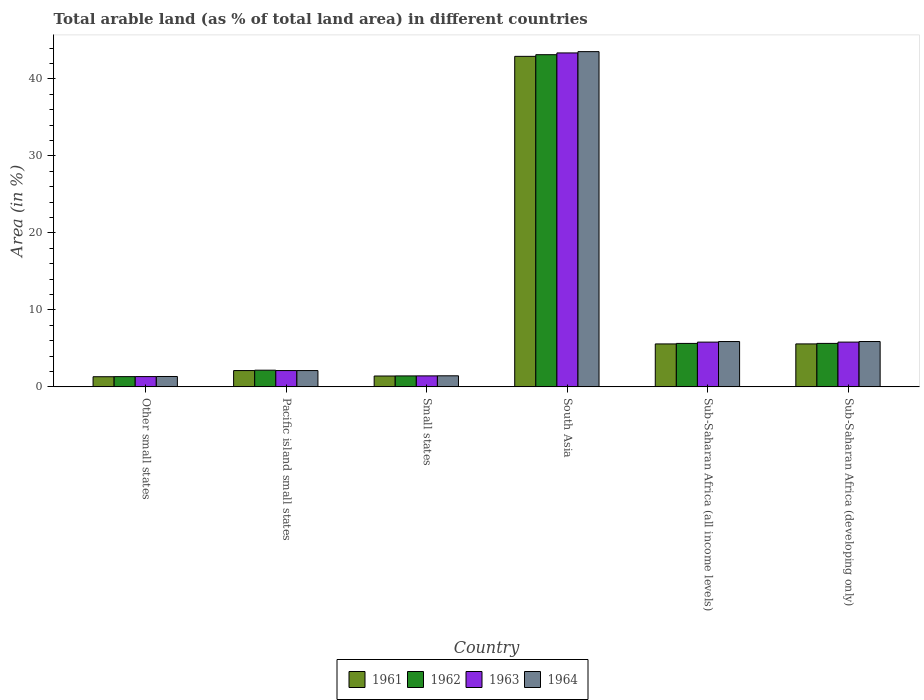Are the number of bars on each tick of the X-axis equal?
Offer a very short reply. Yes. How many bars are there on the 6th tick from the left?
Your answer should be very brief. 4. How many bars are there on the 6th tick from the right?
Ensure brevity in your answer.  4. What is the label of the 4th group of bars from the left?
Offer a very short reply. South Asia. What is the percentage of arable land in 1961 in South Asia?
Provide a short and direct response. 42.92. Across all countries, what is the maximum percentage of arable land in 1963?
Your response must be concise. 43.36. Across all countries, what is the minimum percentage of arable land in 1961?
Offer a very short reply. 1.32. In which country was the percentage of arable land in 1963 maximum?
Make the answer very short. South Asia. In which country was the percentage of arable land in 1961 minimum?
Your response must be concise. Other small states. What is the total percentage of arable land in 1962 in the graph?
Offer a very short reply. 59.34. What is the difference between the percentage of arable land in 1963 in South Asia and that in Sub-Saharan Africa (developing only)?
Your answer should be compact. 37.55. What is the difference between the percentage of arable land in 1964 in Sub-Saharan Africa (all income levels) and the percentage of arable land in 1963 in Other small states?
Make the answer very short. 4.55. What is the average percentage of arable land in 1962 per country?
Offer a very short reply. 9.89. What is the difference between the percentage of arable land of/in 1964 and percentage of arable land of/in 1961 in Sub-Saharan Africa (all income levels)?
Keep it short and to the point. 0.31. In how many countries, is the percentage of arable land in 1962 greater than 40 %?
Offer a terse response. 1. What is the ratio of the percentage of arable land in 1964 in Other small states to that in Pacific island small states?
Give a very brief answer. 0.64. Is the difference between the percentage of arable land in 1964 in South Asia and Sub-Saharan Africa (all income levels) greater than the difference between the percentage of arable land in 1961 in South Asia and Sub-Saharan Africa (all income levels)?
Keep it short and to the point. Yes. What is the difference between the highest and the second highest percentage of arable land in 1962?
Your answer should be very brief. -37.49. What is the difference between the highest and the lowest percentage of arable land in 1964?
Ensure brevity in your answer.  42.18. In how many countries, is the percentage of arable land in 1962 greater than the average percentage of arable land in 1962 taken over all countries?
Your answer should be compact. 1. Is the sum of the percentage of arable land in 1963 in Small states and South Asia greater than the maximum percentage of arable land in 1961 across all countries?
Your answer should be compact. Yes. Is it the case that in every country, the sum of the percentage of arable land in 1962 and percentage of arable land in 1961 is greater than the sum of percentage of arable land in 1964 and percentage of arable land in 1963?
Make the answer very short. No. How many bars are there?
Your answer should be compact. 24. What is the difference between two consecutive major ticks on the Y-axis?
Provide a short and direct response. 10. Are the values on the major ticks of Y-axis written in scientific E-notation?
Ensure brevity in your answer.  No. Does the graph contain any zero values?
Offer a very short reply. No. How many legend labels are there?
Your answer should be compact. 4. How are the legend labels stacked?
Give a very brief answer. Horizontal. What is the title of the graph?
Your answer should be compact. Total arable land (as % of total land area) in different countries. Does "1967" appear as one of the legend labels in the graph?
Offer a very short reply. No. What is the label or title of the X-axis?
Make the answer very short. Country. What is the label or title of the Y-axis?
Make the answer very short. Area (in %). What is the Area (in %) of 1961 in Other small states?
Provide a short and direct response. 1.32. What is the Area (in %) of 1962 in Other small states?
Ensure brevity in your answer.  1.33. What is the Area (in %) in 1963 in Other small states?
Provide a succinct answer. 1.34. What is the Area (in %) of 1964 in Other small states?
Ensure brevity in your answer.  1.35. What is the Area (in %) in 1961 in Pacific island small states?
Give a very brief answer. 2.12. What is the Area (in %) in 1962 in Pacific island small states?
Your response must be concise. 2.17. What is the Area (in %) of 1963 in Pacific island small states?
Your response must be concise. 2.12. What is the Area (in %) in 1964 in Pacific island small states?
Ensure brevity in your answer.  2.12. What is the Area (in %) in 1961 in Small states?
Your response must be concise. 1.41. What is the Area (in %) of 1962 in Small states?
Keep it short and to the point. 1.42. What is the Area (in %) in 1963 in Small states?
Your response must be concise. 1.43. What is the Area (in %) of 1964 in Small states?
Make the answer very short. 1.44. What is the Area (in %) in 1961 in South Asia?
Provide a short and direct response. 42.92. What is the Area (in %) in 1962 in South Asia?
Your answer should be compact. 43.13. What is the Area (in %) in 1963 in South Asia?
Your answer should be very brief. 43.36. What is the Area (in %) of 1964 in South Asia?
Ensure brevity in your answer.  43.53. What is the Area (in %) in 1961 in Sub-Saharan Africa (all income levels)?
Your answer should be very brief. 5.58. What is the Area (in %) in 1962 in Sub-Saharan Africa (all income levels)?
Give a very brief answer. 5.64. What is the Area (in %) of 1963 in Sub-Saharan Africa (all income levels)?
Provide a short and direct response. 5.81. What is the Area (in %) of 1964 in Sub-Saharan Africa (all income levels)?
Your answer should be very brief. 5.89. What is the Area (in %) in 1961 in Sub-Saharan Africa (developing only)?
Your response must be concise. 5.58. What is the Area (in %) of 1962 in Sub-Saharan Africa (developing only)?
Ensure brevity in your answer.  5.65. What is the Area (in %) in 1963 in Sub-Saharan Africa (developing only)?
Your answer should be very brief. 5.81. What is the Area (in %) in 1964 in Sub-Saharan Africa (developing only)?
Your response must be concise. 5.89. Across all countries, what is the maximum Area (in %) of 1961?
Provide a succinct answer. 42.92. Across all countries, what is the maximum Area (in %) of 1962?
Keep it short and to the point. 43.13. Across all countries, what is the maximum Area (in %) of 1963?
Your response must be concise. 43.36. Across all countries, what is the maximum Area (in %) in 1964?
Provide a succinct answer. 43.53. Across all countries, what is the minimum Area (in %) of 1961?
Give a very brief answer. 1.32. Across all countries, what is the minimum Area (in %) in 1962?
Provide a short and direct response. 1.33. Across all countries, what is the minimum Area (in %) in 1963?
Provide a short and direct response. 1.34. Across all countries, what is the minimum Area (in %) of 1964?
Give a very brief answer. 1.35. What is the total Area (in %) in 1961 in the graph?
Provide a succinct answer. 58.92. What is the total Area (in %) of 1962 in the graph?
Provide a succinct answer. 59.34. What is the total Area (in %) in 1963 in the graph?
Your answer should be very brief. 59.87. What is the total Area (in %) of 1964 in the graph?
Provide a succinct answer. 60.21. What is the difference between the Area (in %) in 1961 in Other small states and that in Pacific island small states?
Offer a very short reply. -0.8. What is the difference between the Area (in %) in 1962 in Other small states and that in Pacific island small states?
Make the answer very short. -0.84. What is the difference between the Area (in %) of 1963 in Other small states and that in Pacific island small states?
Your response must be concise. -0.78. What is the difference between the Area (in %) of 1964 in Other small states and that in Pacific island small states?
Ensure brevity in your answer.  -0.77. What is the difference between the Area (in %) in 1961 in Other small states and that in Small states?
Your response must be concise. -0.09. What is the difference between the Area (in %) in 1962 in Other small states and that in Small states?
Give a very brief answer. -0.09. What is the difference between the Area (in %) in 1963 in Other small states and that in Small states?
Provide a succinct answer. -0.09. What is the difference between the Area (in %) of 1964 in Other small states and that in Small states?
Keep it short and to the point. -0.09. What is the difference between the Area (in %) of 1961 in Other small states and that in South Asia?
Your response must be concise. -41.6. What is the difference between the Area (in %) in 1962 in Other small states and that in South Asia?
Give a very brief answer. -41.8. What is the difference between the Area (in %) of 1963 in Other small states and that in South Asia?
Provide a succinct answer. -42.03. What is the difference between the Area (in %) in 1964 in Other small states and that in South Asia?
Your response must be concise. -42.18. What is the difference between the Area (in %) of 1961 in Other small states and that in Sub-Saharan Africa (all income levels)?
Provide a succinct answer. -4.26. What is the difference between the Area (in %) in 1962 in Other small states and that in Sub-Saharan Africa (all income levels)?
Keep it short and to the point. -4.31. What is the difference between the Area (in %) in 1963 in Other small states and that in Sub-Saharan Africa (all income levels)?
Offer a terse response. -4.48. What is the difference between the Area (in %) in 1964 in Other small states and that in Sub-Saharan Africa (all income levels)?
Offer a very short reply. -4.54. What is the difference between the Area (in %) of 1961 in Other small states and that in Sub-Saharan Africa (developing only)?
Ensure brevity in your answer.  -4.26. What is the difference between the Area (in %) in 1962 in Other small states and that in Sub-Saharan Africa (developing only)?
Give a very brief answer. -4.32. What is the difference between the Area (in %) of 1963 in Other small states and that in Sub-Saharan Africa (developing only)?
Your answer should be compact. -4.48. What is the difference between the Area (in %) in 1964 in Other small states and that in Sub-Saharan Africa (developing only)?
Your answer should be very brief. -4.54. What is the difference between the Area (in %) in 1961 in Pacific island small states and that in Small states?
Offer a very short reply. 0.71. What is the difference between the Area (in %) in 1962 in Pacific island small states and that in Small states?
Provide a short and direct response. 0.74. What is the difference between the Area (in %) in 1963 in Pacific island small states and that in Small states?
Make the answer very short. 0.69. What is the difference between the Area (in %) in 1964 in Pacific island small states and that in Small states?
Make the answer very short. 0.68. What is the difference between the Area (in %) in 1961 in Pacific island small states and that in South Asia?
Your answer should be compact. -40.8. What is the difference between the Area (in %) in 1962 in Pacific island small states and that in South Asia?
Give a very brief answer. -40.97. What is the difference between the Area (in %) of 1963 in Pacific island small states and that in South Asia?
Your answer should be very brief. -41.24. What is the difference between the Area (in %) of 1964 in Pacific island small states and that in South Asia?
Give a very brief answer. -41.41. What is the difference between the Area (in %) in 1961 in Pacific island small states and that in Sub-Saharan Africa (all income levels)?
Provide a short and direct response. -3.46. What is the difference between the Area (in %) of 1962 in Pacific island small states and that in Sub-Saharan Africa (all income levels)?
Provide a succinct answer. -3.48. What is the difference between the Area (in %) of 1963 in Pacific island small states and that in Sub-Saharan Africa (all income levels)?
Your answer should be very brief. -3.69. What is the difference between the Area (in %) in 1964 in Pacific island small states and that in Sub-Saharan Africa (all income levels)?
Give a very brief answer. -3.77. What is the difference between the Area (in %) of 1961 in Pacific island small states and that in Sub-Saharan Africa (developing only)?
Ensure brevity in your answer.  -3.46. What is the difference between the Area (in %) in 1962 in Pacific island small states and that in Sub-Saharan Africa (developing only)?
Offer a very short reply. -3.48. What is the difference between the Area (in %) of 1963 in Pacific island small states and that in Sub-Saharan Africa (developing only)?
Your answer should be very brief. -3.7. What is the difference between the Area (in %) in 1964 in Pacific island small states and that in Sub-Saharan Africa (developing only)?
Offer a very short reply. -3.77. What is the difference between the Area (in %) of 1961 in Small states and that in South Asia?
Provide a succinct answer. -41.51. What is the difference between the Area (in %) of 1962 in Small states and that in South Asia?
Provide a short and direct response. -41.71. What is the difference between the Area (in %) of 1963 in Small states and that in South Asia?
Make the answer very short. -41.94. What is the difference between the Area (in %) of 1964 in Small states and that in South Asia?
Your answer should be compact. -42.09. What is the difference between the Area (in %) of 1961 in Small states and that in Sub-Saharan Africa (all income levels)?
Provide a short and direct response. -4.17. What is the difference between the Area (in %) in 1962 in Small states and that in Sub-Saharan Africa (all income levels)?
Your answer should be compact. -4.22. What is the difference between the Area (in %) of 1963 in Small states and that in Sub-Saharan Africa (all income levels)?
Make the answer very short. -4.38. What is the difference between the Area (in %) of 1964 in Small states and that in Sub-Saharan Africa (all income levels)?
Offer a terse response. -4.45. What is the difference between the Area (in %) in 1961 in Small states and that in Sub-Saharan Africa (developing only)?
Ensure brevity in your answer.  -4.17. What is the difference between the Area (in %) of 1962 in Small states and that in Sub-Saharan Africa (developing only)?
Make the answer very short. -4.22. What is the difference between the Area (in %) of 1963 in Small states and that in Sub-Saharan Africa (developing only)?
Your answer should be compact. -4.39. What is the difference between the Area (in %) in 1964 in Small states and that in Sub-Saharan Africa (developing only)?
Keep it short and to the point. -4.45. What is the difference between the Area (in %) in 1961 in South Asia and that in Sub-Saharan Africa (all income levels)?
Provide a succinct answer. 37.34. What is the difference between the Area (in %) of 1962 in South Asia and that in Sub-Saharan Africa (all income levels)?
Offer a terse response. 37.49. What is the difference between the Area (in %) of 1963 in South Asia and that in Sub-Saharan Africa (all income levels)?
Give a very brief answer. 37.55. What is the difference between the Area (in %) of 1964 in South Asia and that in Sub-Saharan Africa (all income levels)?
Your answer should be very brief. 37.64. What is the difference between the Area (in %) in 1961 in South Asia and that in Sub-Saharan Africa (developing only)?
Keep it short and to the point. 37.34. What is the difference between the Area (in %) of 1962 in South Asia and that in Sub-Saharan Africa (developing only)?
Make the answer very short. 37.49. What is the difference between the Area (in %) of 1963 in South Asia and that in Sub-Saharan Africa (developing only)?
Offer a terse response. 37.55. What is the difference between the Area (in %) of 1964 in South Asia and that in Sub-Saharan Africa (developing only)?
Give a very brief answer. 37.64. What is the difference between the Area (in %) in 1961 in Sub-Saharan Africa (all income levels) and that in Sub-Saharan Africa (developing only)?
Keep it short and to the point. -0. What is the difference between the Area (in %) of 1962 in Sub-Saharan Africa (all income levels) and that in Sub-Saharan Africa (developing only)?
Provide a succinct answer. -0. What is the difference between the Area (in %) of 1963 in Sub-Saharan Africa (all income levels) and that in Sub-Saharan Africa (developing only)?
Ensure brevity in your answer.  -0. What is the difference between the Area (in %) of 1964 in Sub-Saharan Africa (all income levels) and that in Sub-Saharan Africa (developing only)?
Your answer should be compact. -0. What is the difference between the Area (in %) of 1961 in Other small states and the Area (in %) of 1962 in Pacific island small states?
Provide a succinct answer. -0.85. What is the difference between the Area (in %) of 1961 in Other small states and the Area (in %) of 1963 in Pacific island small states?
Your answer should be very brief. -0.8. What is the difference between the Area (in %) in 1961 in Other small states and the Area (in %) in 1964 in Pacific island small states?
Provide a succinct answer. -0.8. What is the difference between the Area (in %) of 1962 in Other small states and the Area (in %) of 1963 in Pacific island small states?
Offer a very short reply. -0.79. What is the difference between the Area (in %) in 1962 in Other small states and the Area (in %) in 1964 in Pacific island small states?
Your response must be concise. -0.79. What is the difference between the Area (in %) in 1963 in Other small states and the Area (in %) in 1964 in Pacific island small states?
Make the answer very short. -0.78. What is the difference between the Area (in %) in 1961 in Other small states and the Area (in %) in 1962 in Small states?
Ensure brevity in your answer.  -0.1. What is the difference between the Area (in %) of 1961 in Other small states and the Area (in %) of 1963 in Small states?
Make the answer very short. -0.11. What is the difference between the Area (in %) of 1961 in Other small states and the Area (in %) of 1964 in Small states?
Offer a very short reply. -0.12. What is the difference between the Area (in %) of 1962 in Other small states and the Area (in %) of 1963 in Small states?
Offer a very short reply. -0.1. What is the difference between the Area (in %) of 1962 in Other small states and the Area (in %) of 1964 in Small states?
Your response must be concise. -0.11. What is the difference between the Area (in %) in 1963 in Other small states and the Area (in %) in 1964 in Small states?
Offer a terse response. -0.1. What is the difference between the Area (in %) in 1961 in Other small states and the Area (in %) in 1962 in South Asia?
Your answer should be very brief. -41.82. What is the difference between the Area (in %) of 1961 in Other small states and the Area (in %) of 1963 in South Asia?
Your answer should be very brief. -42.04. What is the difference between the Area (in %) in 1961 in Other small states and the Area (in %) in 1964 in South Asia?
Offer a terse response. -42.21. What is the difference between the Area (in %) in 1962 in Other small states and the Area (in %) in 1963 in South Asia?
Offer a terse response. -42.03. What is the difference between the Area (in %) in 1962 in Other small states and the Area (in %) in 1964 in South Asia?
Your answer should be very brief. -42.2. What is the difference between the Area (in %) in 1963 in Other small states and the Area (in %) in 1964 in South Asia?
Keep it short and to the point. -42.2. What is the difference between the Area (in %) of 1961 in Other small states and the Area (in %) of 1962 in Sub-Saharan Africa (all income levels)?
Your answer should be compact. -4.33. What is the difference between the Area (in %) in 1961 in Other small states and the Area (in %) in 1963 in Sub-Saharan Africa (all income levels)?
Ensure brevity in your answer.  -4.49. What is the difference between the Area (in %) of 1961 in Other small states and the Area (in %) of 1964 in Sub-Saharan Africa (all income levels)?
Your response must be concise. -4.57. What is the difference between the Area (in %) of 1962 in Other small states and the Area (in %) of 1963 in Sub-Saharan Africa (all income levels)?
Give a very brief answer. -4.48. What is the difference between the Area (in %) of 1962 in Other small states and the Area (in %) of 1964 in Sub-Saharan Africa (all income levels)?
Offer a very short reply. -4.56. What is the difference between the Area (in %) in 1963 in Other small states and the Area (in %) in 1964 in Sub-Saharan Africa (all income levels)?
Offer a terse response. -4.55. What is the difference between the Area (in %) in 1961 in Other small states and the Area (in %) in 1962 in Sub-Saharan Africa (developing only)?
Ensure brevity in your answer.  -4.33. What is the difference between the Area (in %) of 1961 in Other small states and the Area (in %) of 1963 in Sub-Saharan Africa (developing only)?
Make the answer very short. -4.49. What is the difference between the Area (in %) of 1961 in Other small states and the Area (in %) of 1964 in Sub-Saharan Africa (developing only)?
Ensure brevity in your answer.  -4.57. What is the difference between the Area (in %) in 1962 in Other small states and the Area (in %) in 1963 in Sub-Saharan Africa (developing only)?
Ensure brevity in your answer.  -4.48. What is the difference between the Area (in %) of 1962 in Other small states and the Area (in %) of 1964 in Sub-Saharan Africa (developing only)?
Your answer should be very brief. -4.56. What is the difference between the Area (in %) in 1963 in Other small states and the Area (in %) in 1964 in Sub-Saharan Africa (developing only)?
Provide a short and direct response. -4.55. What is the difference between the Area (in %) of 1961 in Pacific island small states and the Area (in %) of 1962 in Small states?
Offer a terse response. 0.69. What is the difference between the Area (in %) in 1961 in Pacific island small states and the Area (in %) in 1963 in Small states?
Ensure brevity in your answer.  0.69. What is the difference between the Area (in %) in 1961 in Pacific island small states and the Area (in %) in 1964 in Small states?
Ensure brevity in your answer.  0.68. What is the difference between the Area (in %) in 1962 in Pacific island small states and the Area (in %) in 1963 in Small states?
Your answer should be very brief. 0.74. What is the difference between the Area (in %) in 1962 in Pacific island small states and the Area (in %) in 1964 in Small states?
Your answer should be very brief. 0.73. What is the difference between the Area (in %) of 1963 in Pacific island small states and the Area (in %) of 1964 in Small states?
Your answer should be very brief. 0.68. What is the difference between the Area (in %) of 1961 in Pacific island small states and the Area (in %) of 1962 in South Asia?
Your answer should be very brief. -41.02. What is the difference between the Area (in %) in 1961 in Pacific island small states and the Area (in %) in 1963 in South Asia?
Your answer should be compact. -41.24. What is the difference between the Area (in %) of 1961 in Pacific island small states and the Area (in %) of 1964 in South Asia?
Provide a succinct answer. -41.41. What is the difference between the Area (in %) in 1962 in Pacific island small states and the Area (in %) in 1963 in South Asia?
Provide a succinct answer. -41.2. What is the difference between the Area (in %) in 1962 in Pacific island small states and the Area (in %) in 1964 in South Asia?
Ensure brevity in your answer.  -41.37. What is the difference between the Area (in %) of 1963 in Pacific island small states and the Area (in %) of 1964 in South Asia?
Make the answer very short. -41.41. What is the difference between the Area (in %) of 1961 in Pacific island small states and the Area (in %) of 1962 in Sub-Saharan Africa (all income levels)?
Offer a terse response. -3.53. What is the difference between the Area (in %) of 1961 in Pacific island small states and the Area (in %) of 1963 in Sub-Saharan Africa (all income levels)?
Your response must be concise. -3.69. What is the difference between the Area (in %) in 1961 in Pacific island small states and the Area (in %) in 1964 in Sub-Saharan Africa (all income levels)?
Provide a succinct answer. -3.77. What is the difference between the Area (in %) of 1962 in Pacific island small states and the Area (in %) of 1963 in Sub-Saharan Africa (all income levels)?
Provide a short and direct response. -3.65. What is the difference between the Area (in %) in 1962 in Pacific island small states and the Area (in %) in 1964 in Sub-Saharan Africa (all income levels)?
Ensure brevity in your answer.  -3.72. What is the difference between the Area (in %) in 1963 in Pacific island small states and the Area (in %) in 1964 in Sub-Saharan Africa (all income levels)?
Your answer should be very brief. -3.77. What is the difference between the Area (in %) of 1961 in Pacific island small states and the Area (in %) of 1962 in Sub-Saharan Africa (developing only)?
Provide a succinct answer. -3.53. What is the difference between the Area (in %) in 1961 in Pacific island small states and the Area (in %) in 1963 in Sub-Saharan Africa (developing only)?
Make the answer very short. -3.7. What is the difference between the Area (in %) of 1961 in Pacific island small states and the Area (in %) of 1964 in Sub-Saharan Africa (developing only)?
Give a very brief answer. -3.77. What is the difference between the Area (in %) of 1962 in Pacific island small states and the Area (in %) of 1963 in Sub-Saharan Africa (developing only)?
Provide a short and direct response. -3.65. What is the difference between the Area (in %) in 1962 in Pacific island small states and the Area (in %) in 1964 in Sub-Saharan Africa (developing only)?
Your answer should be compact. -3.72. What is the difference between the Area (in %) in 1963 in Pacific island small states and the Area (in %) in 1964 in Sub-Saharan Africa (developing only)?
Give a very brief answer. -3.77. What is the difference between the Area (in %) of 1961 in Small states and the Area (in %) of 1962 in South Asia?
Your answer should be compact. -41.72. What is the difference between the Area (in %) of 1961 in Small states and the Area (in %) of 1963 in South Asia?
Your answer should be compact. -41.95. What is the difference between the Area (in %) of 1961 in Small states and the Area (in %) of 1964 in South Asia?
Your answer should be compact. -42.12. What is the difference between the Area (in %) of 1962 in Small states and the Area (in %) of 1963 in South Asia?
Offer a very short reply. -41.94. What is the difference between the Area (in %) of 1962 in Small states and the Area (in %) of 1964 in South Asia?
Keep it short and to the point. -42.11. What is the difference between the Area (in %) of 1963 in Small states and the Area (in %) of 1964 in South Asia?
Make the answer very short. -42.1. What is the difference between the Area (in %) in 1961 in Small states and the Area (in %) in 1962 in Sub-Saharan Africa (all income levels)?
Your answer should be very brief. -4.23. What is the difference between the Area (in %) of 1961 in Small states and the Area (in %) of 1963 in Sub-Saharan Africa (all income levels)?
Ensure brevity in your answer.  -4.4. What is the difference between the Area (in %) of 1961 in Small states and the Area (in %) of 1964 in Sub-Saharan Africa (all income levels)?
Your response must be concise. -4.47. What is the difference between the Area (in %) in 1962 in Small states and the Area (in %) in 1963 in Sub-Saharan Africa (all income levels)?
Provide a short and direct response. -4.39. What is the difference between the Area (in %) in 1962 in Small states and the Area (in %) in 1964 in Sub-Saharan Africa (all income levels)?
Keep it short and to the point. -4.46. What is the difference between the Area (in %) of 1963 in Small states and the Area (in %) of 1964 in Sub-Saharan Africa (all income levels)?
Offer a terse response. -4.46. What is the difference between the Area (in %) in 1961 in Small states and the Area (in %) in 1962 in Sub-Saharan Africa (developing only)?
Offer a terse response. -4.23. What is the difference between the Area (in %) in 1961 in Small states and the Area (in %) in 1963 in Sub-Saharan Africa (developing only)?
Make the answer very short. -4.4. What is the difference between the Area (in %) of 1961 in Small states and the Area (in %) of 1964 in Sub-Saharan Africa (developing only)?
Offer a terse response. -4.48. What is the difference between the Area (in %) in 1962 in Small states and the Area (in %) in 1963 in Sub-Saharan Africa (developing only)?
Make the answer very short. -4.39. What is the difference between the Area (in %) in 1962 in Small states and the Area (in %) in 1964 in Sub-Saharan Africa (developing only)?
Give a very brief answer. -4.47. What is the difference between the Area (in %) of 1963 in Small states and the Area (in %) of 1964 in Sub-Saharan Africa (developing only)?
Keep it short and to the point. -4.46. What is the difference between the Area (in %) in 1961 in South Asia and the Area (in %) in 1962 in Sub-Saharan Africa (all income levels)?
Your answer should be compact. 37.27. What is the difference between the Area (in %) in 1961 in South Asia and the Area (in %) in 1963 in Sub-Saharan Africa (all income levels)?
Make the answer very short. 37.11. What is the difference between the Area (in %) in 1961 in South Asia and the Area (in %) in 1964 in Sub-Saharan Africa (all income levels)?
Provide a succinct answer. 37.03. What is the difference between the Area (in %) of 1962 in South Asia and the Area (in %) of 1963 in Sub-Saharan Africa (all income levels)?
Keep it short and to the point. 37.32. What is the difference between the Area (in %) in 1962 in South Asia and the Area (in %) in 1964 in Sub-Saharan Africa (all income levels)?
Ensure brevity in your answer.  37.25. What is the difference between the Area (in %) of 1963 in South Asia and the Area (in %) of 1964 in Sub-Saharan Africa (all income levels)?
Make the answer very short. 37.48. What is the difference between the Area (in %) of 1961 in South Asia and the Area (in %) of 1962 in Sub-Saharan Africa (developing only)?
Make the answer very short. 37.27. What is the difference between the Area (in %) in 1961 in South Asia and the Area (in %) in 1963 in Sub-Saharan Africa (developing only)?
Give a very brief answer. 37.11. What is the difference between the Area (in %) of 1961 in South Asia and the Area (in %) of 1964 in Sub-Saharan Africa (developing only)?
Make the answer very short. 37.03. What is the difference between the Area (in %) of 1962 in South Asia and the Area (in %) of 1963 in Sub-Saharan Africa (developing only)?
Offer a very short reply. 37.32. What is the difference between the Area (in %) in 1962 in South Asia and the Area (in %) in 1964 in Sub-Saharan Africa (developing only)?
Your answer should be compact. 37.25. What is the difference between the Area (in %) of 1963 in South Asia and the Area (in %) of 1964 in Sub-Saharan Africa (developing only)?
Provide a succinct answer. 37.47. What is the difference between the Area (in %) of 1961 in Sub-Saharan Africa (all income levels) and the Area (in %) of 1962 in Sub-Saharan Africa (developing only)?
Your answer should be very brief. -0.07. What is the difference between the Area (in %) of 1961 in Sub-Saharan Africa (all income levels) and the Area (in %) of 1963 in Sub-Saharan Africa (developing only)?
Make the answer very short. -0.24. What is the difference between the Area (in %) in 1961 in Sub-Saharan Africa (all income levels) and the Area (in %) in 1964 in Sub-Saharan Africa (developing only)?
Provide a succinct answer. -0.31. What is the difference between the Area (in %) in 1962 in Sub-Saharan Africa (all income levels) and the Area (in %) in 1963 in Sub-Saharan Africa (developing only)?
Your answer should be compact. -0.17. What is the difference between the Area (in %) of 1962 in Sub-Saharan Africa (all income levels) and the Area (in %) of 1964 in Sub-Saharan Africa (developing only)?
Make the answer very short. -0.24. What is the difference between the Area (in %) in 1963 in Sub-Saharan Africa (all income levels) and the Area (in %) in 1964 in Sub-Saharan Africa (developing only)?
Offer a very short reply. -0.08. What is the average Area (in %) in 1961 per country?
Your answer should be compact. 9.82. What is the average Area (in %) of 1962 per country?
Provide a short and direct response. 9.89. What is the average Area (in %) of 1963 per country?
Offer a terse response. 9.98. What is the average Area (in %) in 1964 per country?
Your answer should be compact. 10.03. What is the difference between the Area (in %) in 1961 and Area (in %) in 1962 in Other small states?
Keep it short and to the point. -0.01. What is the difference between the Area (in %) in 1961 and Area (in %) in 1963 in Other small states?
Offer a very short reply. -0.02. What is the difference between the Area (in %) in 1961 and Area (in %) in 1964 in Other small states?
Give a very brief answer. -0.03. What is the difference between the Area (in %) in 1962 and Area (in %) in 1963 in Other small states?
Provide a succinct answer. -0.01. What is the difference between the Area (in %) in 1962 and Area (in %) in 1964 in Other small states?
Your answer should be very brief. -0.02. What is the difference between the Area (in %) in 1963 and Area (in %) in 1964 in Other small states?
Provide a short and direct response. -0.01. What is the difference between the Area (in %) in 1961 and Area (in %) in 1962 in Pacific island small states?
Make the answer very short. -0.05. What is the difference between the Area (in %) of 1961 and Area (in %) of 1964 in Pacific island small states?
Offer a terse response. 0. What is the difference between the Area (in %) of 1962 and Area (in %) of 1963 in Pacific island small states?
Provide a short and direct response. 0.05. What is the difference between the Area (in %) in 1962 and Area (in %) in 1964 in Pacific island small states?
Offer a very short reply. 0.05. What is the difference between the Area (in %) in 1961 and Area (in %) in 1962 in Small states?
Give a very brief answer. -0.01. What is the difference between the Area (in %) in 1961 and Area (in %) in 1963 in Small states?
Provide a succinct answer. -0.02. What is the difference between the Area (in %) in 1961 and Area (in %) in 1964 in Small states?
Make the answer very short. -0.03. What is the difference between the Area (in %) in 1962 and Area (in %) in 1963 in Small states?
Provide a short and direct response. -0. What is the difference between the Area (in %) of 1962 and Area (in %) of 1964 in Small states?
Your response must be concise. -0.01. What is the difference between the Area (in %) of 1963 and Area (in %) of 1964 in Small states?
Your answer should be very brief. -0.01. What is the difference between the Area (in %) in 1961 and Area (in %) in 1962 in South Asia?
Make the answer very short. -0.22. What is the difference between the Area (in %) of 1961 and Area (in %) of 1963 in South Asia?
Provide a succinct answer. -0.44. What is the difference between the Area (in %) of 1961 and Area (in %) of 1964 in South Asia?
Provide a succinct answer. -0.61. What is the difference between the Area (in %) of 1962 and Area (in %) of 1963 in South Asia?
Your answer should be compact. -0.23. What is the difference between the Area (in %) of 1962 and Area (in %) of 1964 in South Asia?
Offer a very short reply. -0.4. What is the difference between the Area (in %) of 1963 and Area (in %) of 1964 in South Asia?
Offer a terse response. -0.17. What is the difference between the Area (in %) in 1961 and Area (in %) in 1962 in Sub-Saharan Africa (all income levels)?
Your answer should be very brief. -0.07. What is the difference between the Area (in %) in 1961 and Area (in %) in 1963 in Sub-Saharan Africa (all income levels)?
Offer a terse response. -0.23. What is the difference between the Area (in %) of 1961 and Area (in %) of 1964 in Sub-Saharan Africa (all income levels)?
Offer a terse response. -0.31. What is the difference between the Area (in %) in 1962 and Area (in %) in 1963 in Sub-Saharan Africa (all income levels)?
Give a very brief answer. -0.17. What is the difference between the Area (in %) of 1962 and Area (in %) of 1964 in Sub-Saharan Africa (all income levels)?
Give a very brief answer. -0.24. What is the difference between the Area (in %) of 1963 and Area (in %) of 1964 in Sub-Saharan Africa (all income levels)?
Offer a terse response. -0.08. What is the difference between the Area (in %) of 1961 and Area (in %) of 1962 in Sub-Saharan Africa (developing only)?
Give a very brief answer. -0.07. What is the difference between the Area (in %) of 1961 and Area (in %) of 1963 in Sub-Saharan Africa (developing only)?
Keep it short and to the point. -0.23. What is the difference between the Area (in %) of 1961 and Area (in %) of 1964 in Sub-Saharan Africa (developing only)?
Keep it short and to the point. -0.31. What is the difference between the Area (in %) in 1962 and Area (in %) in 1963 in Sub-Saharan Africa (developing only)?
Your answer should be very brief. -0.17. What is the difference between the Area (in %) in 1962 and Area (in %) in 1964 in Sub-Saharan Africa (developing only)?
Offer a terse response. -0.24. What is the difference between the Area (in %) in 1963 and Area (in %) in 1964 in Sub-Saharan Africa (developing only)?
Make the answer very short. -0.08. What is the ratio of the Area (in %) in 1961 in Other small states to that in Pacific island small states?
Make the answer very short. 0.62. What is the ratio of the Area (in %) in 1962 in Other small states to that in Pacific island small states?
Ensure brevity in your answer.  0.61. What is the ratio of the Area (in %) of 1963 in Other small states to that in Pacific island small states?
Your answer should be compact. 0.63. What is the ratio of the Area (in %) in 1964 in Other small states to that in Pacific island small states?
Offer a very short reply. 0.64. What is the ratio of the Area (in %) of 1961 in Other small states to that in Small states?
Your response must be concise. 0.93. What is the ratio of the Area (in %) of 1962 in Other small states to that in Small states?
Your answer should be very brief. 0.93. What is the ratio of the Area (in %) in 1963 in Other small states to that in Small states?
Offer a very short reply. 0.94. What is the ratio of the Area (in %) of 1964 in Other small states to that in Small states?
Your answer should be very brief. 0.94. What is the ratio of the Area (in %) of 1961 in Other small states to that in South Asia?
Your answer should be very brief. 0.03. What is the ratio of the Area (in %) of 1962 in Other small states to that in South Asia?
Keep it short and to the point. 0.03. What is the ratio of the Area (in %) of 1963 in Other small states to that in South Asia?
Ensure brevity in your answer.  0.03. What is the ratio of the Area (in %) in 1964 in Other small states to that in South Asia?
Your response must be concise. 0.03. What is the ratio of the Area (in %) of 1961 in Other small states to that in Sub-Saharan Africa (all income levels)?
Your response must be concise. 0.24. What is the ratio of the Area (in %) in 1962 in Other small states to that in Sub-Saharan Africa (all income levels)?
Your response must be concise. 0.24. What is the ratio of the Area (in %) in 1963 in Other small states to that in Sub-Saharan Africa (all income levels)?
Make the answer very short. 0.23. What is the ratio of the Area (in %) of 1964 in Other small states to that in Sub-Saharan Africa (all income levels)?
Keep it short and to the point. 0.23. What is the ratio of the Area (in %) of 1961 in Other small states to that in Sub-Saharan Africa (developing only)?
Offer a very short reply. 0.24. What is the ratio of the Area (in %) in 1962 in Other small states to that in Sub-Saharan Africa (developing only)?
Give a very brief answer. 0.24. What is the ratio of the Area (in %) in 1963 in Other small states to that in Sub-Saharan Africa (developing only)?
Make the answer very short. 0.23. What is the ratio of the Area (in %) of 1964 in Other small states to that in Sub-Saharan Africa (developing only)?
Your answer should be compact. 0.23. What is the ratio of the Area (in %) in 1962 in Pacific island small states to that in Small states?
Your answer should be very brief. 1.52. What is the ratio of the Area (in %) of 1963 in Pacific island small states to that in Small states?
Give a very brief answer. 1.48. What is the ratio of the Area (in %) in 1964 in Pacific island small states to that in Small states?
Your answer should be very brief. 1.47. What is the ratio of the Area (in %) in 1961 in Pacific island small states to that in South Asia?
Keep it short and to the point. 0.05. What is the ratio of the Area (in %) of 1962 in Pacific island small states to that in South Asia?
Keep it short and to the point. 0.05. What is the ratio of the Area (in %) in 1963 in Pacific island small states to that in South Asia?
Provide a short and direct response. 0.05. What is the ratio of the Area (in %) of 1964 in Pacific island small states to that in South Asia?
Offer a very short reply. 0.05. What is the ratio of the Area (in %) in 1961 in Pacific island small states to that in Sub-Saharan Africa (all income levels)?
Provide a short and direct response. 0.38. What is the ratio of the Area (in %) in 1962 in Pacific island small states to that in Sub-Saharan Africa (all income levels)?
Your response must be concise. 0.38. What is the ratio of the Area (in %) in 1963 in Pacific island small states to that in Sub-Saharan Africa (all income levels)?
Your response must be concise. 0.36. What is the ratio of the Area (in %) in 1964 in Pacific island small states to that in Sub-Saharan Africa (all income levels)?
Your response must be concise. 0.36. What is the ratio of the Area (in %) in 1961 in Pacific island small states to that in Sub-Saharan Africa (developing only)?
Keep it short and to the point. 0.38. What is the ratio of the Area (in %) of 1962 in Pacific island small states to that in Sub-Saharan Africa (developing only)?
Give a very brief answer. 0.38. What is the ratio of the Area (in %) in 1963 in Pacific island small states to that in Sub-Saharan Africa (developing only)?
Your answer should be very brief. 0.36. What is the ratio of the Area (in %) of 1964 in Pacific island small states to that in Sub-Saharan Africa (developing only)?
Give a very brief answer. 0.36. What is the ratio of the Area (in %) in 1961 in Small states to that in South Asia?
Your response must be concise. 0.03. What is the ratio of the Area (in %) of 1962 in Small states to that in South Asia?
Make the answer very short. 0.03. What is the ratio of the Area (in %) in 1963 in Small states to that in South Asia?
Ensure brevity in your answer.  0.03. What is the ratio of the Area (in %) of 1964 in Small states to that in South Asia?
Give a very brief answer. 0.03. What is the ratio of the Area (in %) of 1961 in Small states to that in Sub-Saharan Africa (all income levels)?
Give a very brief answer. 0.25. What is the ratio of the Area (in %) in 1962 in Small states to that in Sub-Saharan Africa (all income levels)?
Give a very brief answer. 0.25. What is the ratio of the Area (in %) of 1963 in Small states to that in Sub-Saharan Africa (all income levels)?
Keep it short and to the point. 0.25. What is the ratio of the Area (in %) of 1964 in Small states to that in Sub-Saharan Africa (all income levels)?
Give a very brief answer. 0.24. What is the ratio of the Area (in %) in 1961 in Small states to that in Sub-Saharan Africa (developing only)?
Provide a succinct answer. 0.25. What is the ratio of the Area (in %) in 1962 in Small states to that in Sub-Saharan Africa (developing only)?
Your answer should be compact. 0.25. What is the ratio of the Area (in %) in 1963 in Small states to that in Sub-Saharan Africa (developing only)?
Offer a very short reply. 0.25. What is the ratio of the Area (in %) in 1964 in Small states to that in Sub-Saharan Africa (developing only)?
Provide a short and direct response. 0.24. What is the ratio of the Area (in %) in 1961 in South Asia to that in Sub-Saharan Africa (all income levels)?
Offer a terse response. 7.7. What is the ratio of the Area (in %) of 1962 in South Asia to that in Sub-Saharan Africa (all income levels)?
Your answer should be compact. 7.64. What is the ratio of the Area (in %) of 1963 in South Asia to that in Sub-Saharan Africa (all income levels)?
Offer a terse response. 7.46. What is the ratio of the Area (in %) in 1964 in South Asia to that in Sub-Saharan Africa (all income levels)?
Keep it short and to the point. 7.39. What is the ratio of the Area (in %) of 1961 in South Asia to that in Sub-Saharan Africa (developing only)?
Your answer should be very brief. 7.69. What is the ratio of the Area (in %) in 1962 in South Asia to that in Sub-Saharan Africa (developing only)?
Provide a succinct answer. 7.64. What is the ratio of the Area (in %) of 1963 in South Asia to that in Sub-Saharan Africa (developing only)?
Your answer should be compact. 7.46. What is the ratio of the Area (in %) of 1964 in South Asia to that in Sub-Saharan Africa (developing only)?
Ensure brevity in your answer.  7.39. What is the ratio of the Area (in %) of 1963 in Sub-Saharan Africa (all income levels) to that in Sub-Saharan Africa (developing only)?
Make the answer very short. 1. What is the difference between the highest and the second highest Area (in %) of 1961?
Make the answer very short. 37.34. What is the difference between the highest and the second highest Area (in %) in 1962?
Offer a very short reply. 37.49. What is the difference between the highest and the second highest Area (in %) in 1963?
Give a very brief answer. 37.55. What is the difference between the highest and the second highest Area (in %) of 1964?
Offer a very short reply. 37.64. What is the difference between the highest and the lowest Area (in %) of 1961?
Keep it short and to the point. 41.6. What is the difference between the highest and the lowest Area (in %) in 1962?
Provide a short and direct response. 41.8. What is the difference between the highest and the lowest Area (in %) of 1963?
Your answer should be very brief. 42.03. What is the difference between the highest and the lowest Area (in %) in 1964?
Your answer should be very brief. 42.18. 